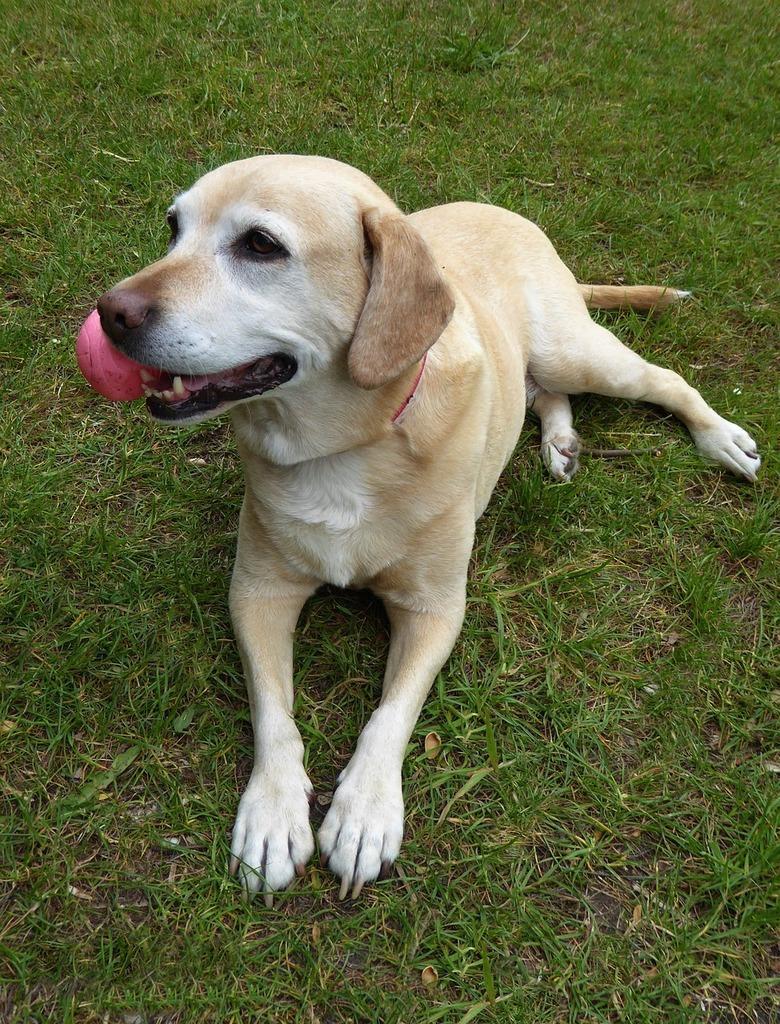Please provide a concise description of this image. In this image we can see a dog. In the background of the image there is the grass. 